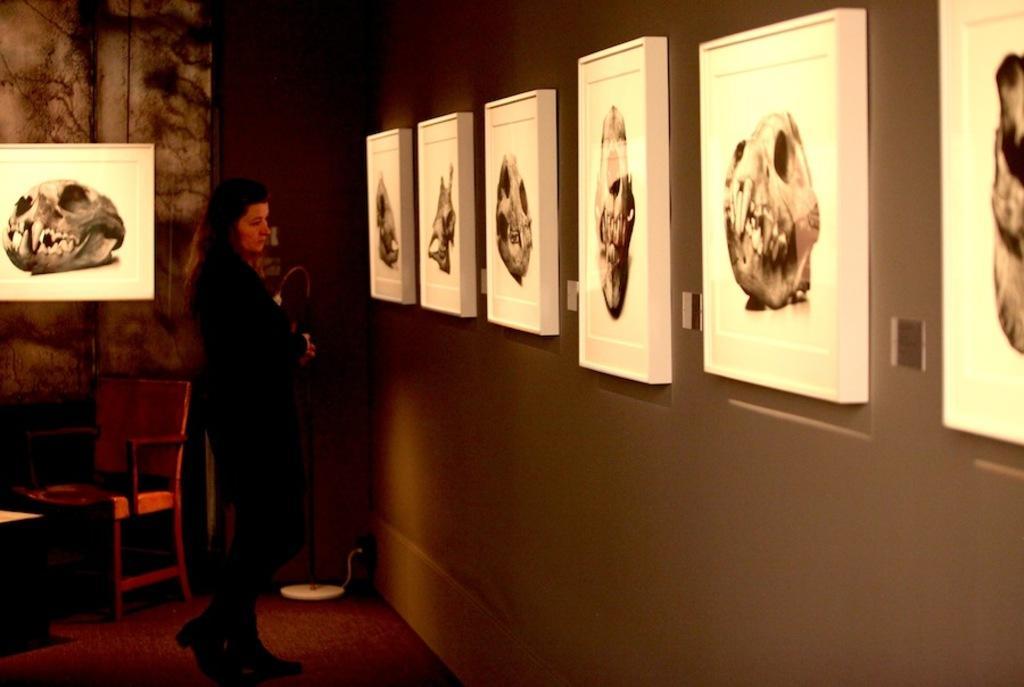Describe this image in one or two sentences. There is a lady. On the right side there is a wall with some pictures. In the back there is a wall with a picture. Near to that there is a chair. 